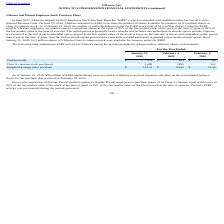According to Vmware's financial document, How many authorized shares were there under the ESPP as of  2020? According to the financial document, 32.3 million. The relevant text states: "f authorized shares under the ESPP was a total of 32.3 million shares. Under the ESPP, eligible VMware employees are granted options to purchase shares at the low..." Also, Which years does the table provide information for ESPP activity for VMware? The document contains multiple relevant values: 2020, 2019, 2018. From the document: "Internal Revenue Code. On June 25, 2019, VMware amended its ESPP to increase the number of shares available for issuance by 9.0 million sha shares of ..." Also, What were the Cash proceeds in 2020? According to the financial document, 172 (in millions). The relevant text states: "Cash proceeds $ 172 $ 161 $ 65..." Also, can you calculate: What was the change in cash proceeds between 2018 and 2019? Based on the calculation: 161-65, the result is 96 (in millions). This is based on the information: "Cash proceeds $ 172 $ 161 $ 65 Cash proceeds $ 172 $ 161 $ 65..." The key data points involved are: 161, 65. Also, can you calculate: What was the change in Class A common stock purchased between 2019 and 2020? Based on the calculation: 1,489-1,895, the result is -406 (in thousands). This is based on the information: "Class A common stock purchased 1,489 1,895 903 Class A common stock purchased 1,489 1,895 903..." The key data points involved are: 1,489, 1,895. Also, can you calculate: What was the percentage change in Weighted-average price per share between 2019 and 2020? To answer this question, I need to perform calculations using the financial data. The calculation is: (115.51-84.95)/84.95, which equals 35.97 (percentage). This is based on the information: "Weighted-average price per share $ 115.51 $ 84.95 $ 72.40 Weighted-average price per share $ 115.51 $ 84.95 $ 72.40..." The key data points involved are: 115.51, 84.95. 